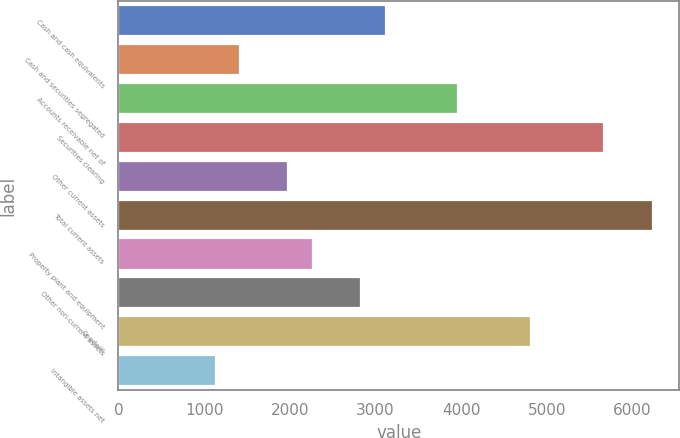Convert chart. <chart><loc_0><loc_0><loc_500><loc_500><bar_chart><fcel>Cash and cash equivalents<fcel>Cash and securities segregated<fcel>Accounts receivable net of<fcel>Securities clearing<fcel>Other current assets<fcel>Total current assets<fcel>Property plant and equipment<fcel>Other non-current assets<fcel>Goodwill<fcel>Intangible assets net<nl><fcel>3116.82<fcel>1417.5<fcel>3966.48<fcel>5665.8<fcel>1983.94<fcel>6232.24<fcel>2267.16<fcel>2833.6<fcel>4816.14<fcel>1134.28<nl></chart> 